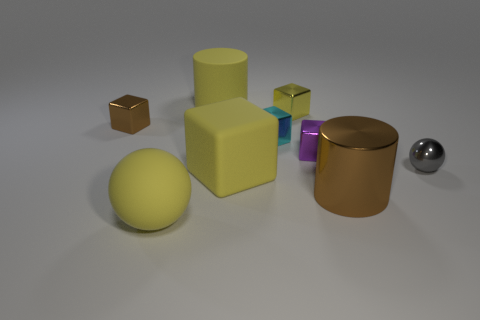Subtract all cyan cubes. How many cubes are left? 4 Subtract all large yellow rubber blocks. How many blocks are left? 4 Subtract 2 blocks. How many blocks are left? 3 Subtract all gray blocks. Subtract all purple cylinders. How many blocks are left? 5 Add 1 tiny cyan things. How many objects exist? 10 Subtract all cylinders. How many objects are left? 7 Subtract 0 green cylinders. How many objects are left? 9 Subtract all gray blocks. Subtract all purple metal blocks. How many objects are left? 8 Add 1 brown metallic cylinders. How many brown metallic cylinders are left? 2 Add 3 big gray balls. How many big gray balls exist? 3 